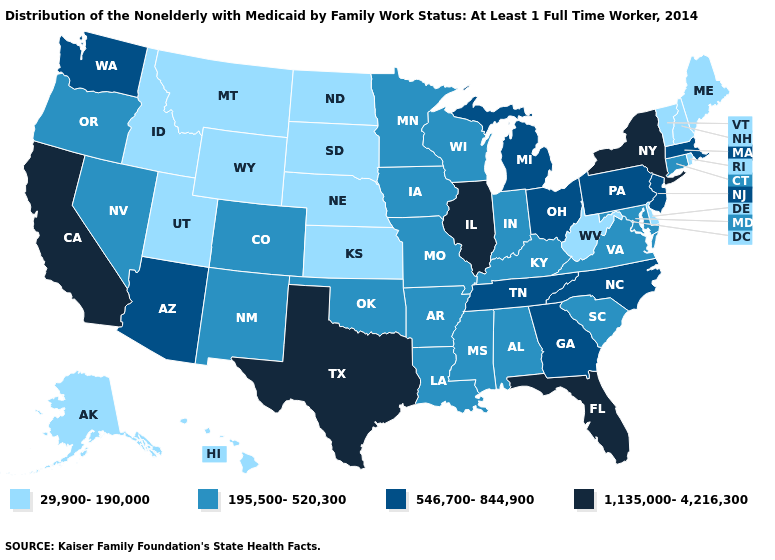What is the lowest value in the USA?
Quick response, please. 29,900-190,000. What is the value of Montana?
Be succinct. 29,900-190,000. Does West Virginia have the lowest value in the South?
Keep it brief. Yes. What is the value of West Virginia?
Be succinct. 29,900-190,000. Which states have the lowest value in the USA?
Give a very brief answer. Alaska, Delaware, Hawaii, Idaho, Kansas, Maine, Montana, Nebraska, New Hampshire, North Dakota, Rhode Island, South Dakota, Utah, Vermont, West Virginia, Wyoming. How many symbols are there in the legend?
Short answer required. 4. What is the value of Colorado?
Keep it brief. 195,500-520,300. What is the highest value in the MidWest ?
Concise answer only. 1,135,000-4,216,300. Does West Virginia have a higher value than Texas?
Be succinct. No. Does Connecticut have a lower value than Massachusetts?
Be succinct. Yes. What is the value of Nevada?
Quick response, please. 195,500-520,300. Among the states that border Iowa , does Wisconsin have the lowest value?
Answer briefly. No. Name the states that have a value in the range 195,500-520,300?
Keep it brief. Alabama, Arkansas, Colorado, Connecticut, Indiana, Iowa, Kentucky, Louisiana, Maryland, Minnesota, Mississippi, Missouri, Nevada, New Mexico, Oklahoma, Oregon, South Carolina, Virginia, Wisconsin. What is the highest value in the West ?
Give a very brief answer. 1,135,000-4,216,300. Among the states that border Delaware , which have the lowest value?
Give a very brief answer. Maryland. 